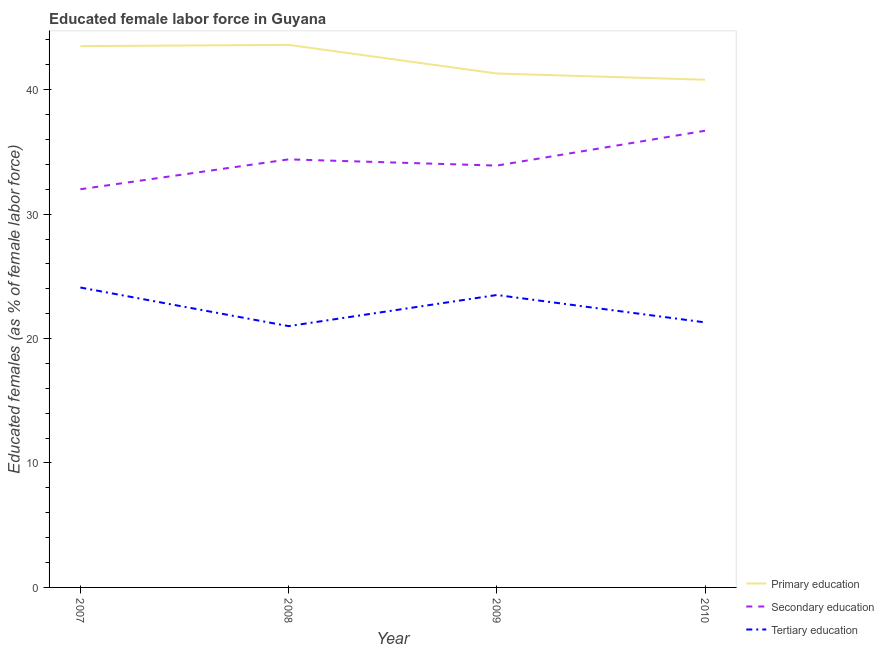How many different coloured lines are there?
Your answer should be compact. 3. Is the number of lines equal to the number of legend labels?
Give a very brief answer. Yes. What is the percentage of female labor force who received primary education in 2007?
Offer a very short reply. 43.5. Across all years, what is the maximum percentage of female labor force who received secondary education?
Ensure brevity in your answer.  36.7. In which year was the percentage of female labor force who received tertiary education minimum?
Your answer should be very brief. 2008. What is the total percentage of female labor force who received primary education in the graph?
Make the answer very short. 169.2. What is the difference between the percentage of female labor force who received primary education in 2007 and that in 2010?
Provide a short and direct response. 2.7. What is the difference between the percentage of female labor force who received primary education in 2008 and the percentage of female labor force who received secondary education in 2007?
Offer a terse response. 11.6. What is the average percentage of female labor force who received primary education per year?
Your answer should be very brief. 42.3. In the year 2007, what is the difference between the percentage of female labor force who received tertiary education and percentage of female labor force who received secondary education?
Your response must be concise. -7.9. What is the ratio of the percentage of female labor force who received secondary education in 2008 to that in 2010?
Give a very brief answer. 0.94. Is the percentage of female labor force who received secondary education in 2009 less than that in 2010?
Give a very brief answer. Yes. What is the difference between the highest and the second highest percentage of female labor force who received primary education?
Keep it short and to the point. 0.1. What is the difference between the highest and the lowest percentage of female labor force who received primary education?
Provide a short and direct response. 2.8. In how many years, is the percentage of female labor force who received primary education greater than the average percentage of female labor force who received primary education taken over all years?
Your answer should be very brief. 2. Is it the case that in every year, the sum of the percentage of female labor force who received primary education and percentage of female labor force who received secondary education is greater than the percentage of female labor force who received tertiary education?
Your answer should be compact. Yes. Does the percentage of female labor force who received primary education monotonically increase over the years?
Make the answer very short. No. Is the percentage of female labor force who received tertiary education strictly less than the percentage of female labor force who received primary education over the years?
Your answer should be very brief. Yes. What is the difference between two consecutive major ticks on the Y-axis?
Ensure brevity in your answer.  10. Does the graph contain any zero values?
Give a very brief answer. No. How many legend labels are there?
Your answer should be very brief. 3. How are the legend labels stacked?
Give a very brief answer. Vertical. What is the title of the graph?
Keep it short and to the point. Educated female labor force in Guyana. What is the label or title of the Y-axis?
Offer a terse response. Educated females (as % of female labor force). What is the Educated females (as % of female labor force) of Primary education in 2007?
Keep it short and to the point. 43.5. What is the Educated females (as % of female labor force) of Secondary education in 2007?
Provide a short and direct response. 32. What is the Educated females (as % of female labor force) of Tertiary education in 2007?
Provide a succinct answer. 24.1. What is the Educated females (as % of female labor force) of Primary education in 2008?
Offer a very short reply. 43.6. What is the Educated females (as % of female labor force) of Secondary education in 2008?
Ensure brevity in your answer.  34.4. What is the Educated females (as % of female labor force) in Tertiary education in 2008?
Make the answer very short. 21. What is the Educated females (as % of female labor force) in Primary education in 2009?
Your answer should be compact. 41.3. What is the Educated females (as % of female labor force) of Secondary education in 2009?
Keep it short and to the point. 33.9. What is the Educated females (as % of female labor force) in Tertiary education in 2009?
Provide a short and direct response. 23.5. What is the Educated females (as % of female labor force) in Primary education in 2010?
Make the answer very short. 40.8. What is the Educated females (as % of female labor force) in Secondary education in 2010?
Your answer should be compact. 36.7. What is the Educated females (as % of female labor force) of Tertiary education in 2010?
Your answer should be compact. 21.3. Across all years, what is the maximum Educated females (as % of female labor force) of Primary education?
Keep it short and to the point. 43.6. Across all years, what is the maximum Educated females (as % of female labor force) in Secondary education?
Provide a succinct answer. 36.7. Across all years, what is the maximum Educated females (as % of female labor force) in Tertiary education?
Keep it short and to the point. 24.1. Across all years, what is the minimum Educated females (as % of female labor force) in Primary education?
Keep it short and to the point. 40.8. What is the total Educated females (as % of female labor force) of Primary education in the graph?
Provide a succinct answer. 169.2. What is the total Educated females (as % of female labor force) in Secondary education in the graph?
Provide a short and direct response. 137. What is the total Educated females (as % of female labor force) of Tertiary education in the graph?
Provide a short and direct response. 89.9. What is the difference between the Educated females (as % of female labor force) of Primary education in 2007 and that in 2008?
Ensure brevity in your answer.  -0.1. What is the difference between the Educated females (as % of female labor force) in Primary education in 2007 and that in 2009?
Keep it short and to the point. 2.2. What is the difference between the Educated females (as % of female labor force) in Tertiary education in 2007 and that in 2009?
Your answer should be very brief. 0.6. What is the difference between the Educated females (as % of female labor force) in Tertiary education in 2007 and that in 2010?
Provide a succinct answer. 2.8. What is the difference between the Educated females (as % of female labor force) of Primary education in 2008 and that in 2009?
Ensure brevity in your answer.  2.3. What is the difference between the Educated females (as % of female labor force) of Tertiary education in 2008 and that in 2010?
Provide a short and direct response. -0.3. What is the difference between the Educated females (as % of female labor force) of Primary education in 2009 and that in 2010?
Your answer should be compact. 0.5. What is the difference between the Educated females (as % of female labor force) of Tertiary education in 2009 and that in 2010?
Give a very brief answer. 2.2. What is the difference between the Educated females (as % of female labor force) of Primary education in 2007 and the Educated females (as % of female labor force) of Secondary education in 2008?
Provide a short and direct response. 9.1. What is the difference between the Educated females (as % of female labor force) in Secondary education in 2007 and the Educated females (as % of female labor force) in Tertiary education in 2008?
Offer a terse response. 11. What is the difference between the Educated females (as % of female labor force) in Secondary education in 2007 and the Educated females (as % of female labor force) in Tertiary education in 2009?
Your answer should be compact. 8.5. What is the difference between the Educated females (as % of female labor force) in Primary education in 2007 and the Educated females (as % of female labor force) in Tertiary education in 2010?
Your answer should be very brief. 22.2. What is the difference between the Educated females (as % of female labor force) of Primary education in 2008 and the Educated females (as % of female labor force) of Tertiary education in 2009?
Your answer should be compact. 20.1. What is the difference between the Educated females (as % of female labor force) in Secondary education in 2008 and the Educated females (as % of female labor force) in Tertiary education in 2009?
Ensure brevity in your answer.  10.9. What is the difference between the Educated females (as % of female labor force) of Primary education in 2008 and the Educated females (as % of female labor force) of Tertiary education in 2010?
Give a very brief answer. 22.3. What is the difference between the Educated females (as % of female labor force) in Secondary education in 2009 and the Educated females (as % of female labor force) in Tertiary education in 2010?
Provide a short and direct response. 12.6. What is the average Educated females (as % of female labor force) in Primary education per year?
Make the answer very short. 42.3. What is the average Educated females (as % of female labor force) of Secondary education per year?
Your answer should be compact. 34.25. What is the average Educated females (as % of female labor force) of Tertiary education per year?
Ensure brevity in your answer.  22.48. In the year 2007, what is the difference between the Educated females (as % of female labor force) of Primary education and Educated females (as % of female labor force) of Tertiary education?
Offer a very short reply. 19.4. In the year 2008, what is the difference between the Educated females (as % of female labor force) in Primary education and Educated females (as % of female labor force) in Tertiary education?
Your response must be concise. 22.6. In the year 2009, what is the difference between the Educated females (as % of female labor force) of Secondary education and Educated females (as % of female labor force) of Tertiary education?
Your response must be concise. 10.4. In the year 2010, what is the difference between the Educated females (as % of female labor force) in Primary education and Educated females (as % of female labor force) in Secondary education?
Your answer should be compact. 4.1. In the year 2010, what is the difference between the Educated females (as % of female labor force) in Secondary education and Educated females (as % of female labor force) in Tertiary education?
Keep it short and to the point. 15.4. What is the ratio of the Educated females (as % of female labor force) in Secondary education in 2007 to that in 2008?
Ensure brevity in your answer.  0.93. What is the ratio of the Educated females (as % of female labor force) in Tertiary education in 2007 to that in 2008?
Provide a succinct answer. 1.15. What is the ratio of the Educated females (as % of female labor force) in Primary education in 2007 to that in 2009?
Your answer should be very brief. 1.05. What is the ratio of the Educated females (as % of female labor force) in Secondary education in 2007 to that in 2009?
Your response must be concise. 0.94. What is the ratio of the Educated females (as % of female labor force) of Tertiary education in 2007 to that in 2009?
Offer a very short reply. 1.03. What is the ratio of the Educated females (as % of female labor force) of Primary education in 2007 to that in 2010?
Provide a short and direct response. 1.07. What is the ratio of the Educated females (as % of female labor force) of Secondary education in 2007 to that in 2010?
Keep it short and to the point. 0.87. What is the ratio of the Educated females (as % of female labor force) in Tertiary education in 2007 to that in 2010?
Give a very brief answer. 1.13. What is the ratio of the Educated females (as % of female labor force) in Primary education in 2008 to that in 2009?
Provide a succinct answer. 1.06. What is the ratio of the Educated females (as % of female labor force) of Secondary education in 2008 to that in 2009?
Your answer should be very brief. 1.01. What is the ratio of the Educated females (as % of female labor force) in Tertiary education in 2008 to that in 2009?
Ensure brevity in your answer.  0.89. What is the ratio of the Educated females (as % of female labor force) of Primary education in 2008 to that in 2010?
Offer a terse response. 1.07. What is the ratio of the Educated females (as % of female labor force) of Secondary education in 2008 to that in 2010?
Provide a succinct answer. 0.94. What is the ratio of the Educated females (as % of female labor force) of Tertiary education in 2008 to that in 2010?
Your answer should be very brief. 0.99. What is the ratio of the Educated females (as % of female labor force) of Primary education in 2009 to that in 2010?
Your response must be concise. 1.01. What is the ratio of the Educated females (as % of female labor force) of Secondary education in 2009 to that in 2010?
Provide a succinct answer. 0.92. What is the ratio of the Educated females (as % of female labor force) of Tertiary education in 2009 to that in 2010?
Your response must be concise. 1.1. What is the difference between the highest and the second highest Educated females (as % of female labor force) in Secondary education?
Your answer should be compact. 2.3. 